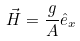<formula> <loc_0><loc_0><loc_500><loc_500>\vec { H } = \frac { g } { A } \hat { e } _ { x }</formula> 